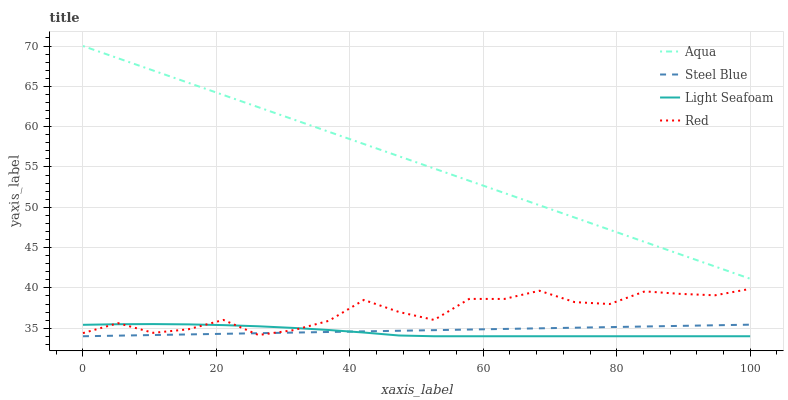Does Light Seafoam have the minimum area under the curve?
Answer yes or no. Yes. Does Aqua have the maximum area under the curve?
Answer yes or no. Yes. Does Steel Blue have the minimum area under the curve?
Answer yes or no. No. Does Steel Blue have the maximum area under the curve?
Answer yes or no. No. Is Steel Blue the smoothest?
Answer yes or no. Yes. Is Red the roughest?
Answer yes or no. Yes. Is Aqua the smoothest?
Answer yes or no. No. Is Aqua the roughest?
Answer yes or no. No. Does Aqua have the lowest value?
Answer yes or no. No. Does Aqua have the highest value?
Answer yes or no. Yes. Does Steel Blue have the highest value?
Answer yes or no. No. Is Steel Blue less than Aqua?
Answer yes or no. Yes. Is Aqua greater than Red?
Answer yes or no. Yes. Does Red intersect Light Seafoam?
Answer yes or no. Yes. Is Red less than Light Seafoam?
Answer yes or no. No. Is Red greater than Light Seafoam?
Answer yes or no. No. Does Steel Blue intersect Aqua?
Answer yes or no. No. 